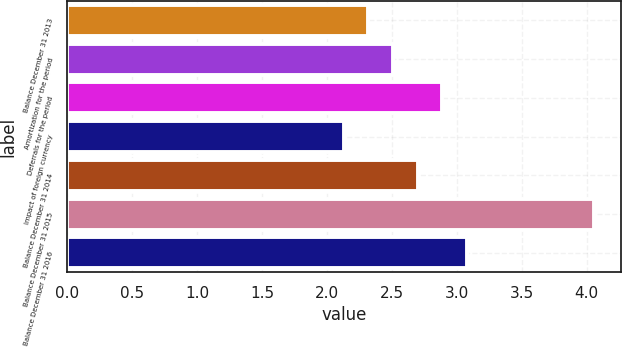Convert chart. <chart><loc_0><loc_0><loc_500><loc_500><bar_chart><fcel>Balance December 31 2013<fcel>Amortization for the period<fcel>Deferrals for the period<fcel>Impact of foreign currency<fcel>Balance December 31 2014<fcel>Balance December 31 2015<fcel>Balance December 31 2016<nl><fcel>2.32<fcel>2.51<fcel>2.89<fcel>2.13<fcel>2.7<fcel>4.06<fcel>3.08<nl></chart> 